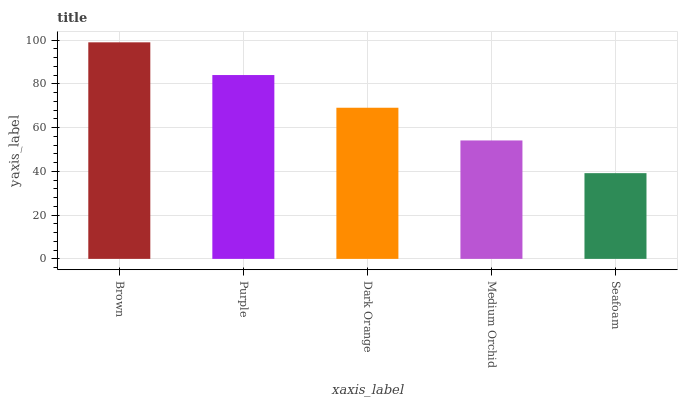Is Seafoam the minimum?
Answer yes or no. Yes. Is Brown the maximum?
Answer yes or no. Yes. Is Purple the minimum?
Answer yes or no. No. Is Purple the maximum?
Answer yes or no. No. Is Brown greater than Purple?
Answer yes or no. Yes. Is Purple less than Brown?
Answer yes or no. Yes. Is Purple greater than Brown?
Answer yes or no. No. Is Brown less than Purple?
Answer yes or no. No. Is Dark Orange the high median?
Answer yes or no. Yes. Is Dark Orange the low median?
Answer yes or no. Yes. Is Purple the high median?
Answer yes or no. No. Is Brown the low median?
Answer yes or no. No. 